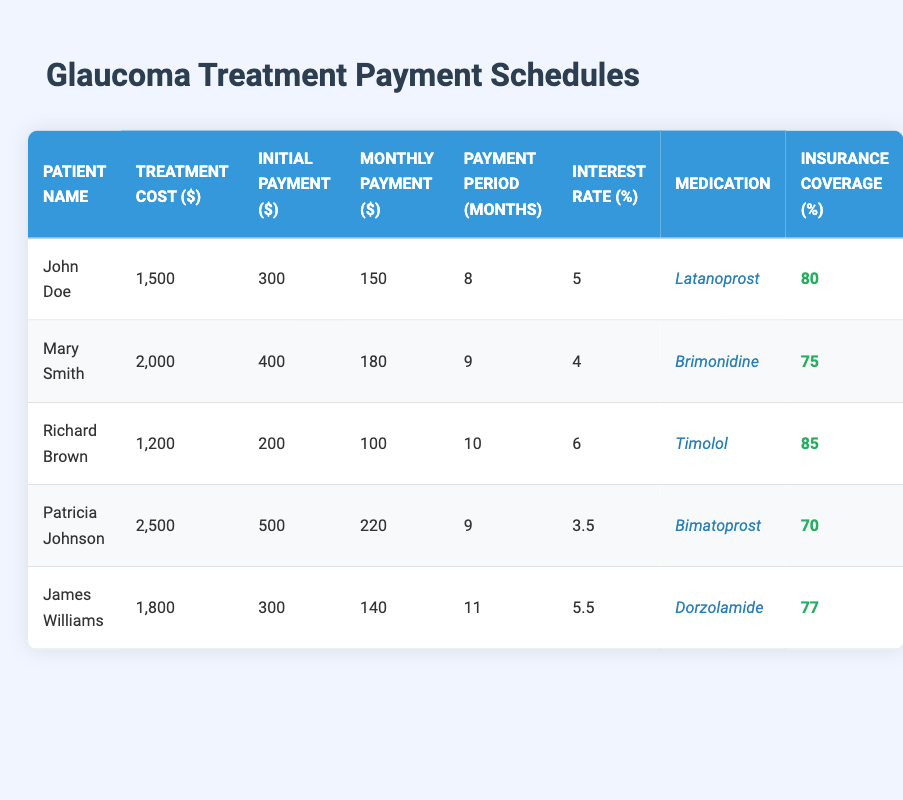What is the total treatment cost for Mary Smith? Mary Smith's treatment cost is directly listed in the table under the "Treatment Cost ($)" column, which shows 2000.
Answer: 2000 How much will John Doe pay in total if he completes his payment plan? John Doe's total payment is calculated as the initial payment plus the total of monthly payments over the period. He pays 300 initially and then 150 monthly for 8 months, so the total is 300 + (150 * 8) = 300 + 1200 = 1500.
Answer: 1500 Which patient has the highest insurance coverage percentage? By comparing the values under the "Insurance Coverage (%)" column, Richard Brown has 85, which is the highest percentage when reviewed against the other patients.
Answer: Richard Brown What is the average monthly payment for all patients? To find the average monthly payment, we sum up all monthly payments: (150 + 180 + 100 + 220 + 140) = 790, then divide by the number of patients (5). Thus, the average is 790 / 5 = 158.
Answer: 158 How does the initial payment for Patricia Johnson compare to Richard Brown? Patricia Johnson's initial payment is 500, whereas Richard Brown's is 200. The difference is 500 - 200 = 300. This shows that Patricia's initial payment is higher by 300 than Richard's.
Answer: 300 Is the treatment cost for James Williams higher than Richard Brown? Comparing the treatment costs, James Williams has 1800 and Richard Brown has 1200. Since 1800 is greater than 1200, the statement is true.
Answer: Yes What is the total payment period in months for all patients combined? To find the total payment period, we need to add the "Payment Period (Months)" values: 8 + 9 + 10 + 9 + 11 = 47. Thus, the total payment period for all patients combined is 47 months.
Answer: 47 Which medication has the lowest interest rate, and what is that rate? By examining the "Interest Rate (%)" column, Patricia Johnson's medication Bimatoprost has the lowest interest rate of 3.5%, which is less than all other listed rates.
Answer: 3.5 How much will Mary Smith pay after her insurance coverage is applied? Mary Smith's treatment cost is 2000 and her insurance coverage is 75%, meaning she will pay 25% of the total. The amount she will pay is 2000 * (25/100) = 500.
Answer: 500 